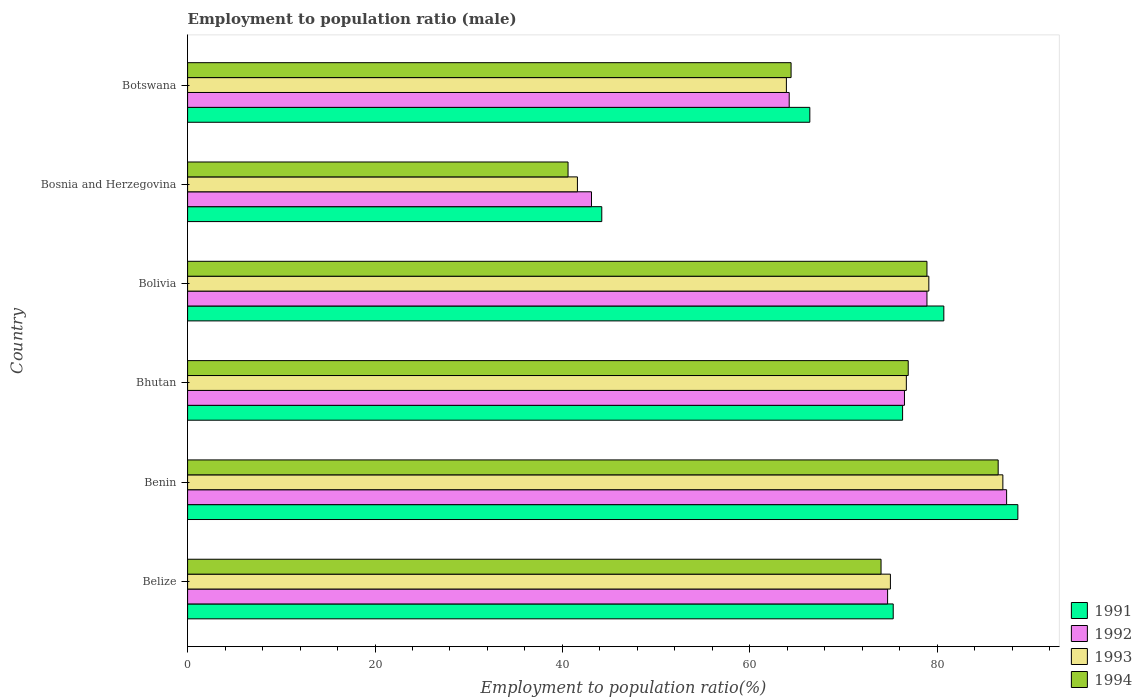How many different coloured bars are there?
Give a very brief answer. 4. How many groups of bars are there?
Provide a succinct answer. 6. Are the number of bars per tick equal to the number of legend labels?
Offer a terse response. Yes. Are the number of bars on each tick of the Y-axis equal?
Your response must be concise. Yes. What is the employment to population ratio in 1993 in Bhutan?
Your answer should be very brief. 76.7. Across all countries, what is the maximum employment to population ratio in 1994?
Your answer should be compact. 86.5. Across all countries, what is the minimum employment to population ratio in 1993?
Give a very brief answer. 41.6. In which country was the employment to population ratio in 1992 maximum?
Offer a terse response. Benin. In which country was the employment to population ratio in 1991 minimum?
Give a very brief answer. Bosnia and Herzegovina. What is the total employment to population ratio in 1992 in the graph?
Provide a short and direct response. 424.8. What is the difference between the employment to population ratio in 1991 in Belize and that in Botswana?
Give a very brief answer. 8.9. What is the difference between the employment to population ratio in 1994 in Botswana and the employment to population ratio in 1992 in Bosnia and Herzegovina?
Your answer should be very brief. 21.3. What is the average employment to population ratio in 1994 per country?
Your answer should be very brief. 70.22. What is the difference between the employment to population ratio in 1991 and employment to population ratio in 1994 in Bosnia and Herzegovina?
Your answer should be compact. 3.6. In how many countries, is the employment to population ratio in 1993 greater than 16 %?
Provide a short and direct response. 6. What is the ratio of the employment to population ratio in 1993 in Bolivia to that in Botswana?
Provide a short and direct response. 1.24. Is the difference between the employment to population ratio in 1991 in Bolivia and Botswana greater than the difference between the employment to population ratio in 1994 in Bolivia and Botswana?
Give a very brief answer. No. What is the difference between the highest and the second highest employment to population ratio in 1994?
Offer a very short reply. 7.6. What is the difference between the highest and the lowest employment to population ratio in 1992?
Offer a terse response. 44.3. Is the sum of the employment to population ratio in 1992 in Bhutan and Botswana greater than the maximum employment to population ratio in 1994 across all countries?
Ensure brevity in your answer.  Yes. What does the 4th bar from the bottom in Bosnia and Herzegovina represents?
Provide a succinct answer. 1994. Is it the case that in every country, the sum of the employment to population ratio in 1992 and employment to population ratio in 1993 is greater than the employment to population ratio in 1991?
Your answer should be very brief. Yes. How many bars are there?
Make the answer very short. 24. Are all the bars in the graph horizontal?
Keep it short and to the point. Yes. Does the graph contain any zero values?
Make the answer very short. No. How many legend labels are there?
Keep it short and to the point. 4. How are the legend labels stacked?
Offer a very short reply. Vertical. What is the title of the graph?
Make the answer very short. Employment to population ratio (male). What is the label or title of the X-axis?
Your response must be concise. Employment to population ratio(%). What is the Employment to population ratio(%) of 1991 in Belize?
Provide a succinct answer. 75.3. What is the Employment to population ratio(%) in 1992 in Belize?
Keep it short and to the point. 74.7. What is the Employment to population ratio(%) of 1993 in Belize?
Your answer should be very brief. 75. What is the Employment to population ratio(%) of 1991 in Benin?
Your answer should be compact. 88.6. What is the Employment to population ratio(%) of 1992 in Benin?
Your answer should be very brief. 87.4. What is the Employment to population ratio(%) in 1994 in Benin?
Provide a succinct answer. 86.5. What is the Employment to population ratio(%) of 1991 in Bhutan?
Your response must be concise. 76.3. What is the Employment to population ratio(%) of 1992 in Bhutan?
Give a very brief answer. 76.5. What is the Employment to population ratio(%) in 1993 in Bhutan?
Your answer should be very brief. 76.7. What is the Employment to population ratio(%) of 1994 in Bhutan?
Give a very brief answer. 76.9. What is the Employment to population ratio(%) in 1991 in Bolivia?
Provide a succinct answer. 80.7. What is the Employment to population ratio(%) in 1992 in Bolivia?
Your answer should be very brief. 78.9. What is the Employment to population ratio(%) of 1993 in Bolivia?
Provide a succinct answer. 79.1. What is the Employment to population ratio(%) of 1994 in Bolivia?
Keep it short and to the point. 78.9. What is the Employment to population ratio(%) in 1991 in Bosnia and Herzegovina?
Keep it short and to the point. 44.2. What is the Employment to population ratio(%) in 1992 in Bosnia and Herzegovina?
Keep it short and to the point. 43.1. What is the Employment to population ratio(%) of 1993 in Bosnia and Herzegovina?
Provide a succinct answer. 41.6. What is the Employment to population ratio(%) in 1994 in Bosnia and Herzegovina?
Provide a short and direct response. 40.6. What is the Employment to population ratio(%) in 1991 in Botswana?
Keep it short and to the point. 66.4. What is the Employment to population ratio(%) in 1992 in Botswana?
Provide a succinct answer. 64.2. What is the Employment to population ratio(%) in 1993 in Botswana?
Make the answer very short. 63.9. What is the Employment to population ratio(%) in 1994 in Botswana?
Offer a very short reply. 64.4. Across all countries, what is the maximum Employment to population ratio(%) in 1991?
Ensure brevity in your answer.  88.6. Across all countries, what is the maximum Employment to population ratio(%) in 1992?
Offer a very short reply. 87.4. Across all countries, what is the maximum Employment to population ratio(%) in 1993?
Make the answer very short. 87. Across all countries, what is the maximum Employment to population ratio(%) of 1994?
Your answer should be compact. 86.5. Across all countries, what is the minimum Employment to population ratio(%) in 1991?
Offer a very short reply. 44.2. Across all countries, what is the minimum Employment to population ratio(%) in 1992?
Ensure brevity in your answer.  43.1. Across all countries, what is the minimum Employment to population ratio(%) in 1993?
Offer a terse response. 41.6. Across all countries, what is the minimum Employment to population ratio(%) in 1994?
Ensure brevity in your answer.  40.6. What is the total Employment to population ratio(%) in 1991 in the graph?
Ensure brevity in your answer.  431.5. What is the total Employment to population ratio(%) of 1992 in the graph?
Your response must be concise. 424.8. What is the total Employment to population ratio(%) in 1993 in the graph?
Make the answer very short. 423.3. What is the total Employment to population ratio(%) in 1994 in the graph?
Provide a short and direct response. 421.3. What is the difference between the Employment to population ratio(%) in 1991 in Belize and that in Benin?
Your answer should be compact. -13.3. What is the difference between the Employment to population ratio(%) of 1992 in Belize and that in Benin?
Keep it short and to the point. -12.7. What is the difference between the Employment to population ratio(%) of 1993 in Belize and that in Benin?
Your answer should be very brief. -12. What is the difference between the Employment to population ratio(%) in 1992 in Belize and that in Bhutan?
Keep it short and to the point. -1.8. What is the difference between the Employment to population ratio(%) in 1993 in Belize and that in Bhutan?
Provide a short and direct response. -1.7. What is the difference between the Employment to population ratio(%) in 1994 in Belize and that in Bhutan?
Your response must be concise. -2.9. What is the difference between the Employment to population ratio(%) of 1991 in Belize and that in Bolivia?
Your answer should be compact. -5.4. What is the difference between the Employment to population ratio(%) in 1994 in Belize and that in Bolivia?
Offer a terse response. -4.9. What is the difference between the Employment to population ratio(%) in 1991 in Belize and that in Bosnia and Herzegovina?
Make the answer very short. 31.1. What is the difference between the Employment to population ratio(%) of 1992 in Belize and that in Bosnia and Herzegovina?
Your answer should be compact. 31.6. What is the difference between the Employment to population ratio(%) in 1993 in Belize and that in Bosnia and Herzegovina?
Your answer should be very brief. 33.4. What is the difference between the Employment to population ratio(%) in 1994 in Belize and that in Bosnia and Herzegovina?
Your response must be concise. 33.4. What is the difference between the Employment to population ratio(%) in 1991 in Belize and that in Botswana?
Provide a short and direct response. 8.9. What is the difference between the Employment to population ratio(%) of 1992 in Belize and that in Botswana?
Give a very brief answer. 10.5. What is the difference between the Employment to population ratio(%) in 1994 in Belize and that in Botswana?
Provide a short and direct response. 9.6. What is the difference between the Employment to population ratio(%) of 1991 in Benin and that in Bhutan?
Make the answer very short. 12.3. What is the difference between the Employment to population ratio(%) of 1991 in Benin and that in Bolivia?
Keep it short and to the point. 7.9. What is the difference between the Employment to population ratio(%) in 1993 in Benin and that in Bolivia?
Ensure brevity in your answer.  7.9. What is the difference between the Employment to population ratio(%) of 1994 in Benin and that in Bolivia?
Your answer should be very brief. 7.6. What is the difference between the Employment to population ratio(%) of 1991 in Benin and that in Bosnia and Herzegovina?
Your answer should be very brief. 44.4. What is the difference between the Employment to population ratio(%) of 1992 in Benin and that in Bosnia and Herzegovina?
Your response must be concise. 44.3. What is the difference between the Employment to population ratio(%) in 1993 in Benin and that in Bosnia and Herzegovina?
Your response must be concise. 45.4. What is the difference between the Employment to population ratio(%) of 1994 in Benin and that in Bosnia and Herzegovina?
Provide a succinct answer. 45.9. What is the difference between the Employment to population ratio(%) of 1992 in Benin and that in Botswana?
Offer a terse response. 23.2. What is the difference between the Employment to population ratio(%) in 1993 in Benin and that in Botswana?
Give a very brief answer. 23.1. What is the difference between the Employment to population ratio(%) of 1994 in Benin and that in Botswana?
Provide a succinct answer. 22.1. What is the difference between the Employment to population ratio(%) of 1991 in Bhutan and that in Bolivia?
Provide a succinct answer. -4.4. What is the difference between the Employment to population ratio(%) in 1994 in Bhutan and that in Bolivia?
Ensure brevity in your answer.  -2. What is the difference between the Employment to population ratio(%) in 1991 in Bhutan and that in Bosnia and Herzegovina?
Make the answer very short. 32.1. What is the difference between the Employment to population ratio(%) of 1992 in Bhutan and that in Bosnia and Herzegovina?
Your answer should be compact. 33.4. What is the difference between the Employment to population ratio(%) of 1993 in Bhutan and that in Bosnia and Herzegovina?
Provide a succinct answer. 35.1. What is the difference between the Employment to population ratio(%) in 1994 in Bhutan and that in Bosnia and Herzegovina?
Offer a very short reply. 36.3. What is the difference between the Employment to population ratio(%) of 1991 in Bhutan and that in Botswana?
Provide a short and direct response. 9.9. What is the difference between the Employment to population ratio(%) in 1994 in Bhutan and that in Botswana?
Make the answer very short. 12.5. What is the difference between the Employment to population ratio(%) in 1991 in Bolivia and that in Bosnia and Herzegovina?
Your answer should be very brief. 36.5. What is the difference between the Employment to population ratio(%) in 1992 in Bolivia and that in Bosnia and Herzegovina?
Your answer should be compact. 35.8. What is the difference between the Employment to population ratio(%) of 1993 in Bolivia and that in Bosnia and Herzegovina?
Your answer should be very brief. 37.5. What is the difference between the Employment to population ratio(%) in 1994 in Bolivia and that in Bosnia and Herzegovina?
Provide a succinct answer. 38.3. What is the difference between the Employment to population ratio(%) in 1991 in Bolivia and that in Botswana?
Give a very brief answer. 14.3. What is the difference between the Employment to population ratio(%) of 1992 in Bolivia and that in Botswana?
Your answer should be compact. 14.7. What is the difference between the Employment to population ratio(%) of 1993 in Bolivia and that in Botswana?
Offer a terse response. 15.2. What is the difference between the Employment to population ratio(%) in 1991 in Bosnia and Herzegovina and that in Botswana?
Provide a short and direct response. -22.2. What is the difference between the Employment to population ratio(%) in 1992 in Bosnia and Herzegovina and that in Botswana?
Your answer should be compact. -21.1. What is the difference between the Employment to population ratio(%) of 1993 in Bosnia and Herzegovina and that in Botswana?
Provide a short and direct response. -22.3. What is the difference between the Employment to population ratio(%) of 1994 in Bosnia and Herzegovina and that in Botswana?
Offer a very short reply. -23.8. What is the difference between the Employment to population ratio(%) of 1991 in Belize and the Employment to population ratio(%) of 1994 in Benin?
Make the answer very short. -11.2. What is the difference between the Employment to population ratio(%) of 1991 in Belize and the Employment to population ratio(%) of 1992 in Bhutan?
Your answer should be compact. -1.2. What is the difference between the Employment to population ratio(%) in 1992 in Belize and the Employment to population ratio(%) in 1993 in Bhutan?
Provide a short and direct response. -2. What is the difference between the Employment to population ratio(%) of 1991 in Belize and the Employment to population ratio(%) of 1994 in Bolivia?
Your answer should be compact. -3.6. What is the difference between the Employment to population ratio(%) in 1992 in Belize and the Employment to population ratio(%) in 1993 in Bolivia?
Give a very brief answer. -4.4. What is the difference between the Employment to population ratio(%) of 1992 in Belize and the Employment to population ratio(%) of 1994 in Bolivia?
Ensure brevity in your answer.  -4.2. What is the difference between the Employment to population ratio(%) in 1993 in Belize and the Employment to population ratio(%) in 1994 in Bolivia?
Your response must be concise. -3.9. What is the difference between the Employment to population ratio(%) in 1991 in Belize and the Employment to population ratio(%) in 1992 in Bosnia and Herzegovina?
Your response must be concise. 32.2. What is the difference between the Employment to population ratio(%) of 1991 in Belize and the Employment to population ratio(%) of 1993 in Bosnia and Herzegovina?
Make the answer very short. 33.7. What is the difference between the Employment to population ratio(%) of 1991 in Belize and the Employment to population ratio(%) of 1994 in Bosnia and Herzegovina?
Ensure brevity in your answer.  34.7. What is the difference between the Employment to population ratio(%) in 1992 in Belize and the Employment to population ratio(%) in 1993 in Bosnia and Herzegovina?
Your answer should be compact. 33.1. What is the difference between the Employment to population ratio(%) of 1992 in Belize and the Employment to population ratio(%) of 1994 in Bosnia and Herzegovina?
Provide a short and direct response. 34.1. What is the difference between the Employment to population ratio(%) of 1993 in Belize and the Employment to population ratio(%) of 1994 in Bosnia and Herzegovina?
Your answer should be compact. 34.4. What is the difference between the Employment to population ratio(%) of 1991 in Belize and the Employment to population ratio(%) of 1993 in Botswana?
Provide a short and direct response. 11.4. What is the difference between the Employment to population ratio(%) of 1991 in Belize and the Employment to population ratio(%) of 1994 in Botswana?
Keep it short and to the point. 10.9. What is the difference between the Employment to population ratio(%) of 1992 in Belize and the Employment to population ratio(%) of 1993 in Botswana?
Offer a very short reply. 10.8. What is the difference between the Employment to population ratio(%) of 1992 in Belize and the Employment to population ratio(%) of 1994 in Botswana?
Your answer should be compact. 10.3. What is the difference between the Employment to population ratio(%) in 1993 in Belize and the Employment to population ratio(%) in 1994 in Botswana?
Give a very brief answer. 10.6. What is the difference between the Employment to population ratio(%) in 1991 in Benin and the Employment to population ratio(%) in 1994 in Bhutan?
Your answer should be very brief. 11.7. What is the difference between the Employment to population ratio(%) of 1991 in Benin and the Employment to population ratio(%) of 1992 in Bolivia?
Provide a succinct answer. 9.7. What is the difference between the Employment to population ratio(%) in 1992 in Benin and the Employment to population ratio(%) in 1993 in Bolivia?
Your answer should be very brief. 8.3. What is the difference between the Employment to population ratio(%) of 1991 in Benin and the Employment to population ratio(%) of 1992 in Bosnia and Herzegovina?
Keep it short and to the point. 45.5. What is the difference between the Employment to population ratio(%) of 1991 in Benin and the Employment to population ratio(%) of 1993 in Bosnia and Herzegovina?
Provide a short and direct response. 47. What is the difference between the Employment to population ratio(%) in 1991 in Benin and the Employment to population ratio(%) in 1994 in Bosnia and Herzegovina?
Keep it short and to the point. 48. What is the difference between the Employment to population ratio(%) in 1992 in Benin and the Employment to population ratio(%) in 1993 in Bosnia and Herzegovina?
Your answer should be compact. 45.8. What is the difference between the Employment to population ratio(%) of 1992 in Benin and the Employment to population ratio(%) of 1994 in Bosnia and Herzegovina?
Keep it short and to the point. 46.8. What is the difference between the Employment to population ratio(%) of 1993 in Benin and the Employment to population ratio(%) of 1994 in Bosnia and Herzegovina?
Provide a short and direct response. 46.4. What is the difference between the Employment to population ratio(%) of 1991 in Benin and the Employment to population ratio(%) of 1992 in Botswana?
Ensure brevity in your answer.  24.4. What is the difference between the Employment to population ratio(%) in 1991 in Benin and the Employment to population ratio(%) in 1993 in Botswana?
Provide a short and direct response. 24.7. What is the difference between the Employment to population ratio(%) in 1991 in Benin and the Employment to population ratio(%) in 1994 in Botswana?
Provide a succinct answer. 24.2. What is the difference between the Employment to population ratio(%) of 1992 in Benin and the Employment to population ratio(%) of 1993 in Botswana?
Provide a short and direct response. 23.5. What is the difference between the Employment to population ratio(%) in 1993 in Benin and the Employment to population ratio(%) in 1994 in Botswana?
Keep it short and to the point. 22.6. What is the difference between the Employment to population ratio(%) in 1991 in Bhutan and the Employment to population ratio(%) in 1994 in Bolivia?
Your response must be concise. -2.6. What is the difference between the Employment to population ratio(%) in 1992 in Bhutan and the Employment to population ratio(%) in 1993 in Bolivia?
Your response must be concise. -2.6. What is the difference between the Employment to population ratio(%) of 1992 in Bhutan and the Employment to population ratio(%) of 1994 in Bolivia?
Give a very brief answer. -2.4. What is the difference between the Employment to population ratio(%) of 1991 in Bhutan and the Employment to population ratio(%) of 1992 in Bosnia and Herzegovina?
Make the answer very short. 33.2. What is the difference between the Employment to population ratio(%) in 1991 in Bhutan and the Employment to population ratio(%) in 1993 in Bosnia and Herzegovina?
Your response must be concise. 34.7. What is the difference between the Employment to population ratio(%) of 1991 in Bhutan and the Employment to population ratio(%) of 1994 in Bosnia and Herzegovina?
Your response must be concise. 35.7. What is the difference between the Employment to population ratio(%) of 1992 in Bhutan and the Employment to population ratio(%) of 1993 in Bosnia and Herzegovina?
Your answer should be compact. 34.9. What is the difference between the Employment to population ratio(%) of 1992 in Bhutan and the Employment to population ratio(%) of 1994 in Bosnia and Herzegovina?
Offer a terse response. 35.9. What is the difference between the Employment to population ratio(%) in 1993 in Bhutan and the Employment to population ratio(%) in 1994 in Bosnia and Herzegovina?
Provide a succinct answer. 36.1. What is the difference between the Employment to population ratio(%) in 1991 in Bhutan and the Employment to population ratio(%) in 1994 in Botswana?
Ensure brevity in your answer.  11.9. What is the difference between the Employment to population ratio(%) in 1992 in Bhutan and the Employment to population ratio(%) in 1993 in Botswana?
Your answer should be very brief. 12.6. What is the difference between the Employment to population ratio(%) of 1993 in Bhutan and the Employment to population ratio(%) of 1994 in Botswana?
Ensure brevity in your answer.  12.3. What is the difference between the Employment to population ratio(%) of 1991 in Bolivia and the Employment to population ratio(%) of 1992 in Bosnia and Herzegovina?
Your answer should be compact. 37.6. What is the difference between the Employment to population ratio(%) of 1991 in Bolivia and the Employment to population ratio(%) of 1993 in Bosnia and Herzegovina?
Give a very brief answer. 39.1. What is the difference between the Employment to population ratio(%) of 1991 in Bolivia and the Employment to population ratio(%) of 1994 in Bosnia and Herzegovina?
Offer a terse response. 40.1. What is the difference between the Employment to population ratio(%) in 1992 in Bolivia and the Employment to population ratio(%) in 1993 in Bosnia and Herzegovina?
Keep it short and to the point. 37.3. What is the difference between the Employment to population ratio(%) of 1992 in Bolivia and the Employment to population ratio(%) of 1994 in Bosnia and Herzegovina?
Make the answer very short. 38.3. What is the difference between the Employment to population ratio(%) in 1993 in Bolivia and the Employment to population ratio(%) in 1994 in Bosnia and Herzegovina?
Give a very brief answer. 38.5. What is the difference between the Employment to population ratio(%) in 1991 in Bolivia and the Employment to population ratio(%) in 1994 in Botswana?
Provide a succinct answer. 16.3. What is the difference between the Employment to population ratio(%) in 1992 in Bolivia and the Employment to population ratio(%) in 1994 in Botswana?
Make the answer very short. 14.5. What is the difference between the Employment to population ratio(%) of 1991 in Bosnia and Herzegovina and the Employment to population ratio(%) of 1992 in Botswana?
Give a very brief answer. -20. What is the difference between the Employment to population ratio(%) of 1991 in Bosnia and Herzegovina and the Employment to population ratio(%) of 1993 in Botswana?
Your answer should be very brief. -19.7. What is the difference between the Employment to population ratio(%) of 1991 in Bosnia and Herzegovina and the Employment to population ratio(%) of 1994 in Botswana?
Provide a short and direct response. -20.2. What is the difference between the Employment to population ratio(%) in 1992 in Bosnia and Herzegovina and the Employment to population ratio(%) in 1993 in Botswana?
Your answer should be compact. -20.8. What is the difference between the Employment to population ratio(%) in 1992 in Bosnia and Herzegovina and the Employment to population ratio(%) in 1994 in Botswana?
Your response must be concise. -21.3. What is the difference between the Employment to population ratio(%) in 1993 in Bosnia and Herzegovina and the Employment to population ratio(%) in 1994 in Botswana?
Keep it short and to the point. -22.8. What is the average Employment to population ratio(%) in 1991 per country?
Provide a short and direct response. 71.92. What is the average Employment to population ratio(%) in 1992 per country?
Provide a short and direct response. 70.8. What is the average Employment to population ratio(%) in 1993 per country?
Your answer should be very brief. 70.55. What is the average Employment to population ratio(%) in 1994 per country?
Keep it short and to the point. 70.22. What is the difference between the Employment to population ratio(%) in 1991 and Employment to population ratio(%) in 1993 in Belize?
Keep it short and to the point. 0.3. What is the difference between the Employment to population ratio(%) in 1991 and Employment to population ratio(%) in 1994 in Belize?
Offer a very short reply. 1.3. What is the difference between the Employment to population ratio(%) of 1992 and Employment to population ratio(%) of 1993 in Belize?
Your answer should be very brief. -0.3. What is the difference between the Employment to population ratio(%) in 1993 and Employment to population ratio(%) in 1994 in Belize?
Give a very brief answer. 1. What is the difference between the Employment to population ratio(%) of 1991 and Employment to population ratio(%) of 1992 in Benin?
Make the answer very short. 1.2. What is the difference between the Employment to population ratio(%) in 1991 and Employment to population ratio(%) in 1993 in Benin?
Offer a very short reply. 1.6. What is the difference between the Employment to population ratio(%) in 1991 and Employment to population ratio(%) in 1994 in Benin?
Provide a short and direct response. 2.1. What is the difference between the Employment to population ratio(%) of 1992 and Employment to population ratio(%) of 1993 in Benin?
Keep it short and to the point. 0.4. What is the difference between the Employment to population ratio(%) of 1992 and Employment to population ratio(%) of 1994 in Benin?
Make the answer very short. 0.9. What is the difference between the Employment to population ratio(%) of 1993 and Employment to population ratio(%) of 1994 in Benin?
Offer a very short reply. 0.5. What is the difference between the Employment to population ratio(%) of 1991 and Employment to population ratio(%) of 1993 in Bhutan?
Your answer should be compact. -0.4. What is the difference between the Employment to population ratio(%) of 1991 and Employment to population ratio(%) of 1994 in Bhutan?
Offer a terse response. -0.6. What is the difference between the Employment to population ratio(%) of 1992 and Employment to population ratio(%) of 1993 in Bhutan?
Offer a very short reply. -0.2. What is the difference between the Employment to population ratio(%) in 1991 and Employment to population ratio(%) in 1992 in Bolivia?
Keep it short and to the point. 1.8. What is the difference between the Employment to population ratio(%) in 1991 and Employment to population ratio(%) in 1994 in Bolivia?
Your answer should be very brief. 1.8. What is the difference between the Employment to population ratio(%) in 1992 and Employment to population ratio(%) in 1994 in Bolivia?
Offer a very short reply. 0. What is the difference between the Employment to population ratio(%) of 1991 and Employment to population ratio(%) of 1994 in Bosnia and Herzegovina?
Make the answer very short. 3.6. What is the difference between the Employment to population ratio(%) in 1992 and Employment to population ratio(%) in 1994 in Bosnia and Herzegovina?
Provide a succinct answer. 2.5. What is the difference between the Employment to population ratio(%) of 1993 and Employment to population ratio(%) of 1994 in Bosnia and Herzegovina?
Offer a very short reply. 1. What is the difference between the Employment to population ratio(%) of 1991 and Employment to population ratio(%) of 1994 in Botswana?
Your answer should be very brief. 2. What is the difference between the Employment to population ratio(%) in 1992 and Employment to population ratio(%) in 1993 in Botswana?
Your response must be concise. 0.3. What is the difference between the Employment to population ratio(%) of 1993 and Employment to population ratio(%) of 1994 in Botswana?
Provide a short and direct response. -0.5. What is the ratio of the Employment to population ratio(%) in 1991 in Belize to that in Benin?
Offer a very short reply. 0.85. What is the ratio of the Employment to population ratio(%) of 1992 in Belize to that in Benin?
Ensure brevity in your answer.  0.85. What is the ratio of the Employment to population ratio(%) in 1993 in Belize to that in Benin?
Provide a succinct answer. 0.86. What is the ratio of the Employment to population ratio(%) of 1994 in Belize to that in Benin?
Your answer should be very brief. 0.86. What is the ratio of the Employment to population ratio(%) in 1991 in Belize to that in Bhutan?
Offer a terse response. 0.99. What is the ratio of the Employment to population ratio(%) in 1992 in Belize to that in Bhutan?
Make the answer very short. 0.98. What is the ratio of the Employment to population ratio(%) in 1993 in Belize to that in Bhutan?
Make the answer very short. 0.98. What is the ratio of the Employment to population ratio(%) in 1994 in Belize to that in Bhutan?
Keep it short and to the point. 0.96. What is the ratio of the Employment to population ratio(%) of 1991 in Belize to that in Bolivia?
Ensure brevity in your answer.  0.93. What is the ratio of the Employment to population ratio(%) in 1992 in Belize to that in Bolivia?
Provide a succinct answer. 0.95. What is the ratio of the Employment to population ratio(%) of 1993 in Belize to that in Bolivia?
Your answer should be very brief. 0.95. What is the ratio of the Employment to population ratio(%) of 1994 in Belize to that in Bolivia?
Your answer should be compact. 0.94. What is the ratio of the Employment to population ratio(%) of 1991 in Belize to that in Bosnia and Herzegovina?
Your response must be concise. 1.7. What is the ratio of the Employment to population ratio(%) in 1992 in Belize to that in Bosnia and Herzegovina?
Your answer should be very brief. 1.73. What is the ratio of the Employment to population ratio(%) of 1993 in Belize to that in Bosnia and Herzegovina?
Give a very brief answer. 1.8. What is the ratio of the Employment to population ratio(%) of 1994 in Belize to that in Bosnia and Herzegovina?
Offer a very short reply. 1.82. What is the ratio of the Employment to population ratio(%) of 1991 in Belize to that in Botswana?
Make the answer very short. 1.13. What is the ratio of the Employment to population ratio(%) of 1992 in Belize to that in Botswana?
Keep it short and to the point. 1.16. What is the ratio of the Employment to population ratio(%) of 1993 in Belize to that in Botswana?
Provide a short and direct response. 1.17. What is the ratio of the Employment to population ratio(%) of 1994 in Belize to that in Botswana?
Your answer should be very brief. 1.15. What is the ratio of the Employment to population ratio(%) of 1991 in Benin to that in Bhutan?
Your response must be concise. 1.16. What is the ratio of the Employment to population ratio(%) of 1992 in Benin to that in Bhutan?
Ensure brevity in your answer.  1.14. What is the ratio of the Employment to population ratio(%) in 1993 in Benin to that in Bhutan?
Provide a short and direct response. 1.13. What is the ratio of the Employment to population ratio(%) in 1994 in Benin to that in Bhutan?
Make the answer very short. 1.12. What is the ratio of the Employment to population ratio(%) in 1991 in Benin to that in Bolivia?
Give a very brief answer. 1.1. What is the ratio of the Employment to population ratio(%) in 1992 in Benin to that in Bolivia?
Offer a very short reply. 1.11. What is the ratio of the Employment to population ratio(%) of 1993 in Benin to that in Bolivia?
Your answer should be very brief. 1.1. What is the ratio of the Employment to population ratio(%) of 1994 in Benin to that in Bolivia?
Your response must be concise. 1.1. What is the ratio of the Employment to population ratio(%) of 1991 in Benin to that in Bosnia and Herzegovina?
Provide a succinct answer. 2. What is the ratio of the Employment to population ratio(%) of 1992 in Benin to that in Bosnia and Herzegovina?
Give a very brief answer. 2.03. What is the ratio of the Employment to population ratio(%) in 1993 in Benin to that in Bosnia and Herzegovina?
Ensure brevity in your answer.  2.09. What is the ratio of the Employment to population ratio(%) of 1994 in Benin to that in Bosnia and Herzegovina?
Make the answer very short. 2.13. What is the ratio of the Employment to population ratio(%) of 1991 in Benin to that in Botswana?
Provide a succinct answer. 1.33. What is the ratio of the Employment to population ratio(%) of 1992 in Benin to that in Botswana?
Keep it short and to the point. 1.36. What is the ratio of the Employment to population ratio(%) of 1993 in Benin to that in Botswana?
Your answer should be compact. 1.36. What is the ratio of the Employment to population ratio(%) in 1994 in Benin to that in Botswana?
Your response must be concise. 1.34. What is the ratio of the Employment to population ratio(%) of 1991 in Bhutan to that in Bolivia?
Offer a very short reply. 0.95. What is the ratio of the Employment to population ratio(%) of 1992 in Bhutan to that in Bolivia?
Give a very brief answer. 0.97. What is the ratio of the Employment to population ratio(%) of 1993 in Bhutan to that in Bolivia?
Your answer should be very brief. 0.97. What is the ratio of the Employment to population ratio(%) in 1994 in Bhutan to that in Bolivia?
Provide a short and direct response. 0.97. What is the ratio of the Employment to population ratio(%) of 1991 in Bhutan to that in Bosnia and Herzegovina?
Give a very brief answer. 1.73. What is the ratio of the Employment to population ratio(%) in 1992 in Bhutan to that in Bosnia and Herzegovina?
Keep it short and to the point. 1.77. What is the ratio of the Employment to population ratio(%) in 1993 in Bhutan to that in Bosnia and Herzegovina?
Offer a very short reply. 1.84. What is the ratio of the Employment to population ratio(%) of 1994 in Bhutan to that in Bosnia and Herzegovina?
Your answer should be very brief. 1.89. What is the ratio of the Employment to population ratio(%) of 1991 in Bhutan to that in Botswana?
Ensure brevity in your answer.  1.15. What is the ratio of the Employment to population ratio(%) of 1992 in Bhutan to that in Botswana?
Offer a very short reply. 1.19. What is the ratio of the Employment to population ratio(%) in 1993 in Bhutan to that in Botswana?
Provide a succinct answer. 1.2. What is the ratio of the Employment to population ratio(%) in 1994 in Bhutan to that in Botswana?
Provide a short and direct response. 1.19. What is the ratio of the Employment to population ratio(%) of 1991 in Bolivia to that in Bosnia and Herzegovina?
Give a very brief answer. 1.83. What is the ratio of the Employment to population ratio(%) of 1992 in Bolivia to that in Bosnia and Herzegovina?
Your answer should be compact. 1.83. What is the ratio of the Employment to population ratio(%) of 1993 in Bolivia to that in Bosnia and Herzegovina?
Ensure brevity in your answer.  1.9. What is the ratio of the Employment to population ratio(%) in 1994 in Bolivia to that in Bosnia and Herzegovina?
Keep it short and to the point. 1.94. What is the ratio of the Employment to population ratio(%) of 1991 in Bolivia to that in Botswana?
Your response must be concise. 1.22. What is the ratio of the Employment to population ratio(%) of 1992 in Bolivia to that in Botswana?
Ensure brevity in your answer.  1.23. What is the ratio of the Employment to population ratio(%) in 1993 in Bolivia to that in Botswana?
Make the answer very short. 1.24. What is the ratio of the Employment to population ratio(%) in 1994 in Bolivia to that in Botswana?
Your answer should be very brief. 1.23. What is the ratio of the Employment to population ratio(%) of 1991 in Bosnia and Herzegovina to that in Botswana?
Make the answer very short. 0.67. What is the ratio of the Employment to population ratio(%) in 1992 in Bosnia and Herzegovina to that in Botswana?
Ensure brevity in your answer.  0.67. What is the ratio of the Employment to population ratio(%) in 1993 in Bosnia and Herzegovina to that in Botswana?
Offer a terse response. 0.65. What is the ratio of the Employment to population ratio(%) of 1994 in Bosnia and Herzegovina to that in Botswana?
Your response must be concise. 0.63. What is the difference between the highest and the second highest Employment to population ratio(%) in 1991?
Provide a succinct answer. 7.9. What is the difference between the highest and the second highest Employment to population ratio(%) in 1993?
Your response must be concise. 7.9. What is the difference between the highest and the lowest Employment to population ratio(%) of 1991?
Make the answer very short. 44.4. What is the difference between the highest and the lowest Employment to population ratio(%) in 1992?
Make the answer very short. 44.3. What is the difference between the highest and the lowest Employment to population ratio(%) in 1993?
Offer a very short reply. 45.4. What is the difference between the highest and the lowest Employment to population ratio(%) in 1994?
Ensure brevity in your answer.  45.9. 